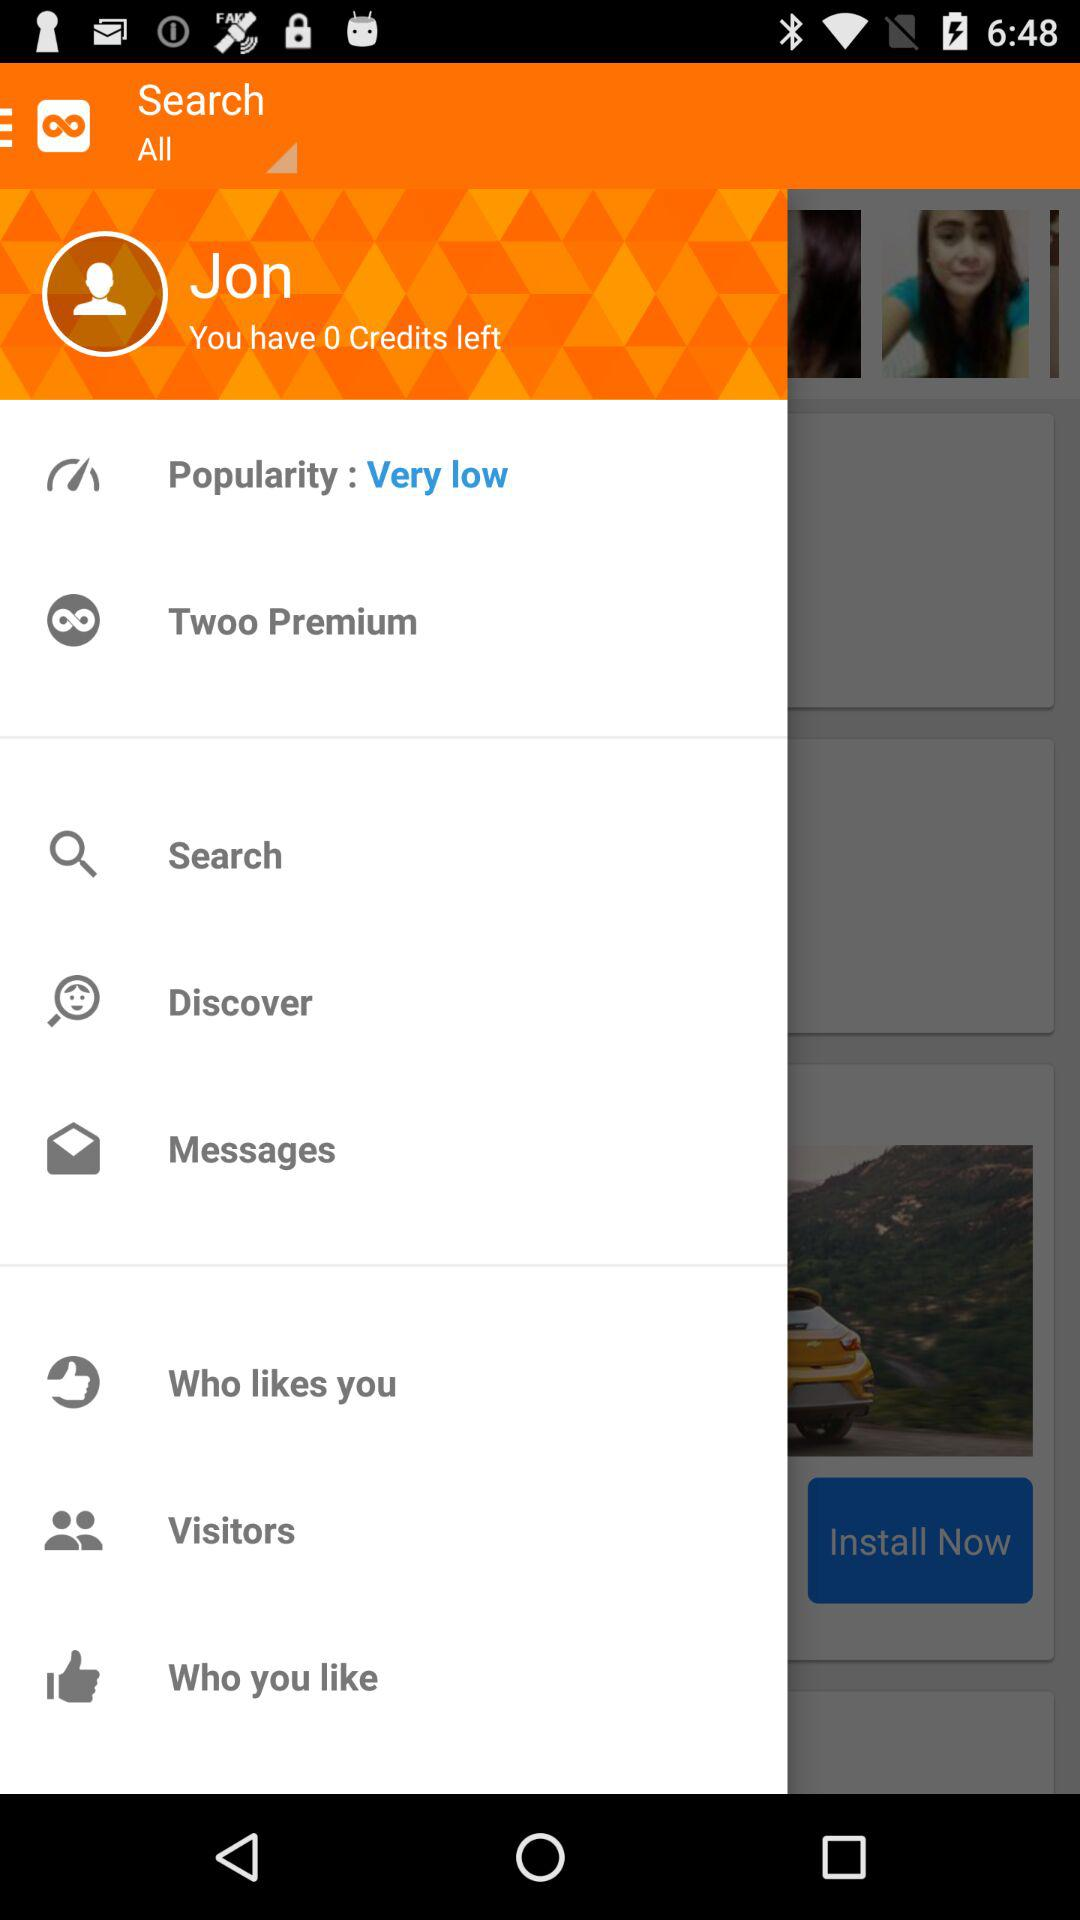How many credits are left? There are 0 credit left. 